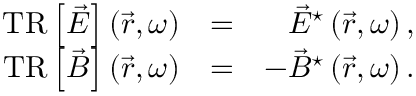<formula> <loc_0><loc_0><loc_500><loc_500>\begin{array} { r l r } { T R \left [ \vec { E } \right ] \left ( \vec { r } , \omega \right ) } & { = } & { \vec { E } ^ { ^ { * } } \left ( \vec { r } , \omega \right ) , } \\ { T R \left [ \vec { B } \right ] \left ( \vec { r } , \omega \right ) } & { = } & { - \vec { B } ^ { ^ { * } } \left ( \vec { r } , \omega \right ) . } \end{array}</formula> 